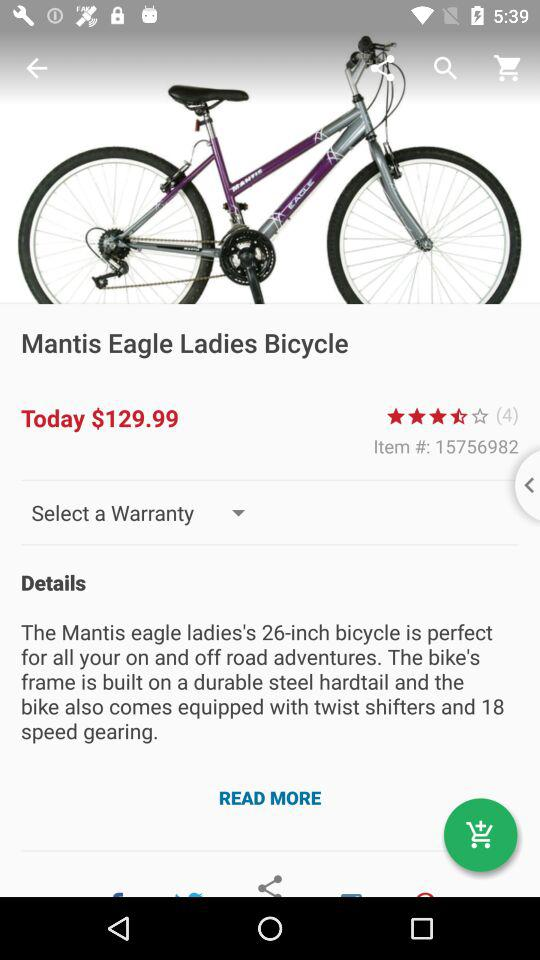What is the rating? The rating is 3.5 stars. 